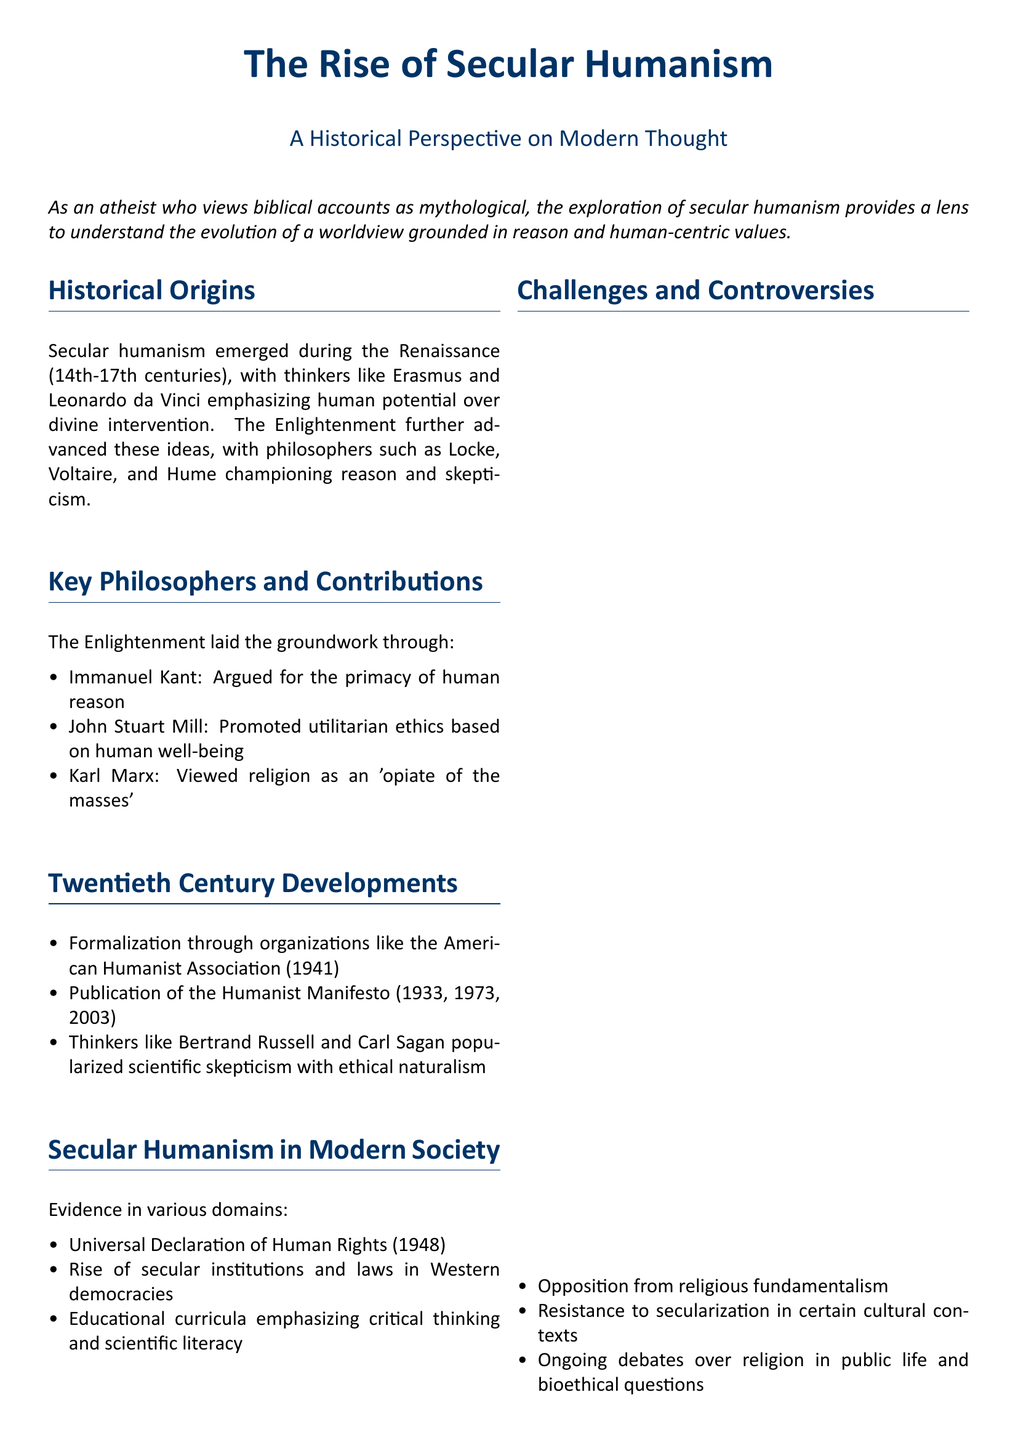What period did secular humanism emerge? Secular humanism emerged during the Renaissance, which spans the 14th to 17th centuries.
Answer: 14th-17th centuries Who emphasized human potential over divine intervention? Erasmus and Leonardo da Vinci were key figures who emphasized human potential.
Answer: Erasmus and Leonardo da Vinci What philosophical concept did Immanuel Kant argue for? Immanuel Kant argued for the primacy of human reason.
Answer: Primacy of human reason When was the American Humanist Association formed? The American Humanist Association was formalized in 1941.
Answer: 1941 What is the purpose of the Universal Declaration of Human Rights? It serves as evidence of universal human rights in modern society.
Answer: Universal human rights What did Karl Marx view religion as? Karl Marx viewed religion as an 'opiate of the masses.'
Answer: Opiate of the masses Which thinkers popularized scientific skepticism? Bertrand Russell and Carl Sagan were notable thinkers who did this.
Answer: Bertrand Russell and Carl Sagan What ongoing debate is mentioned in the challenges section? The ongoing debate includes issues regarding religion in public life.
Answer: Religion in public life What framework does secular humanism provide according to the conclusion? It provides a framework for understanding the world without supernatural explanations.
Answer: Understanding the world without supernatural explanations 